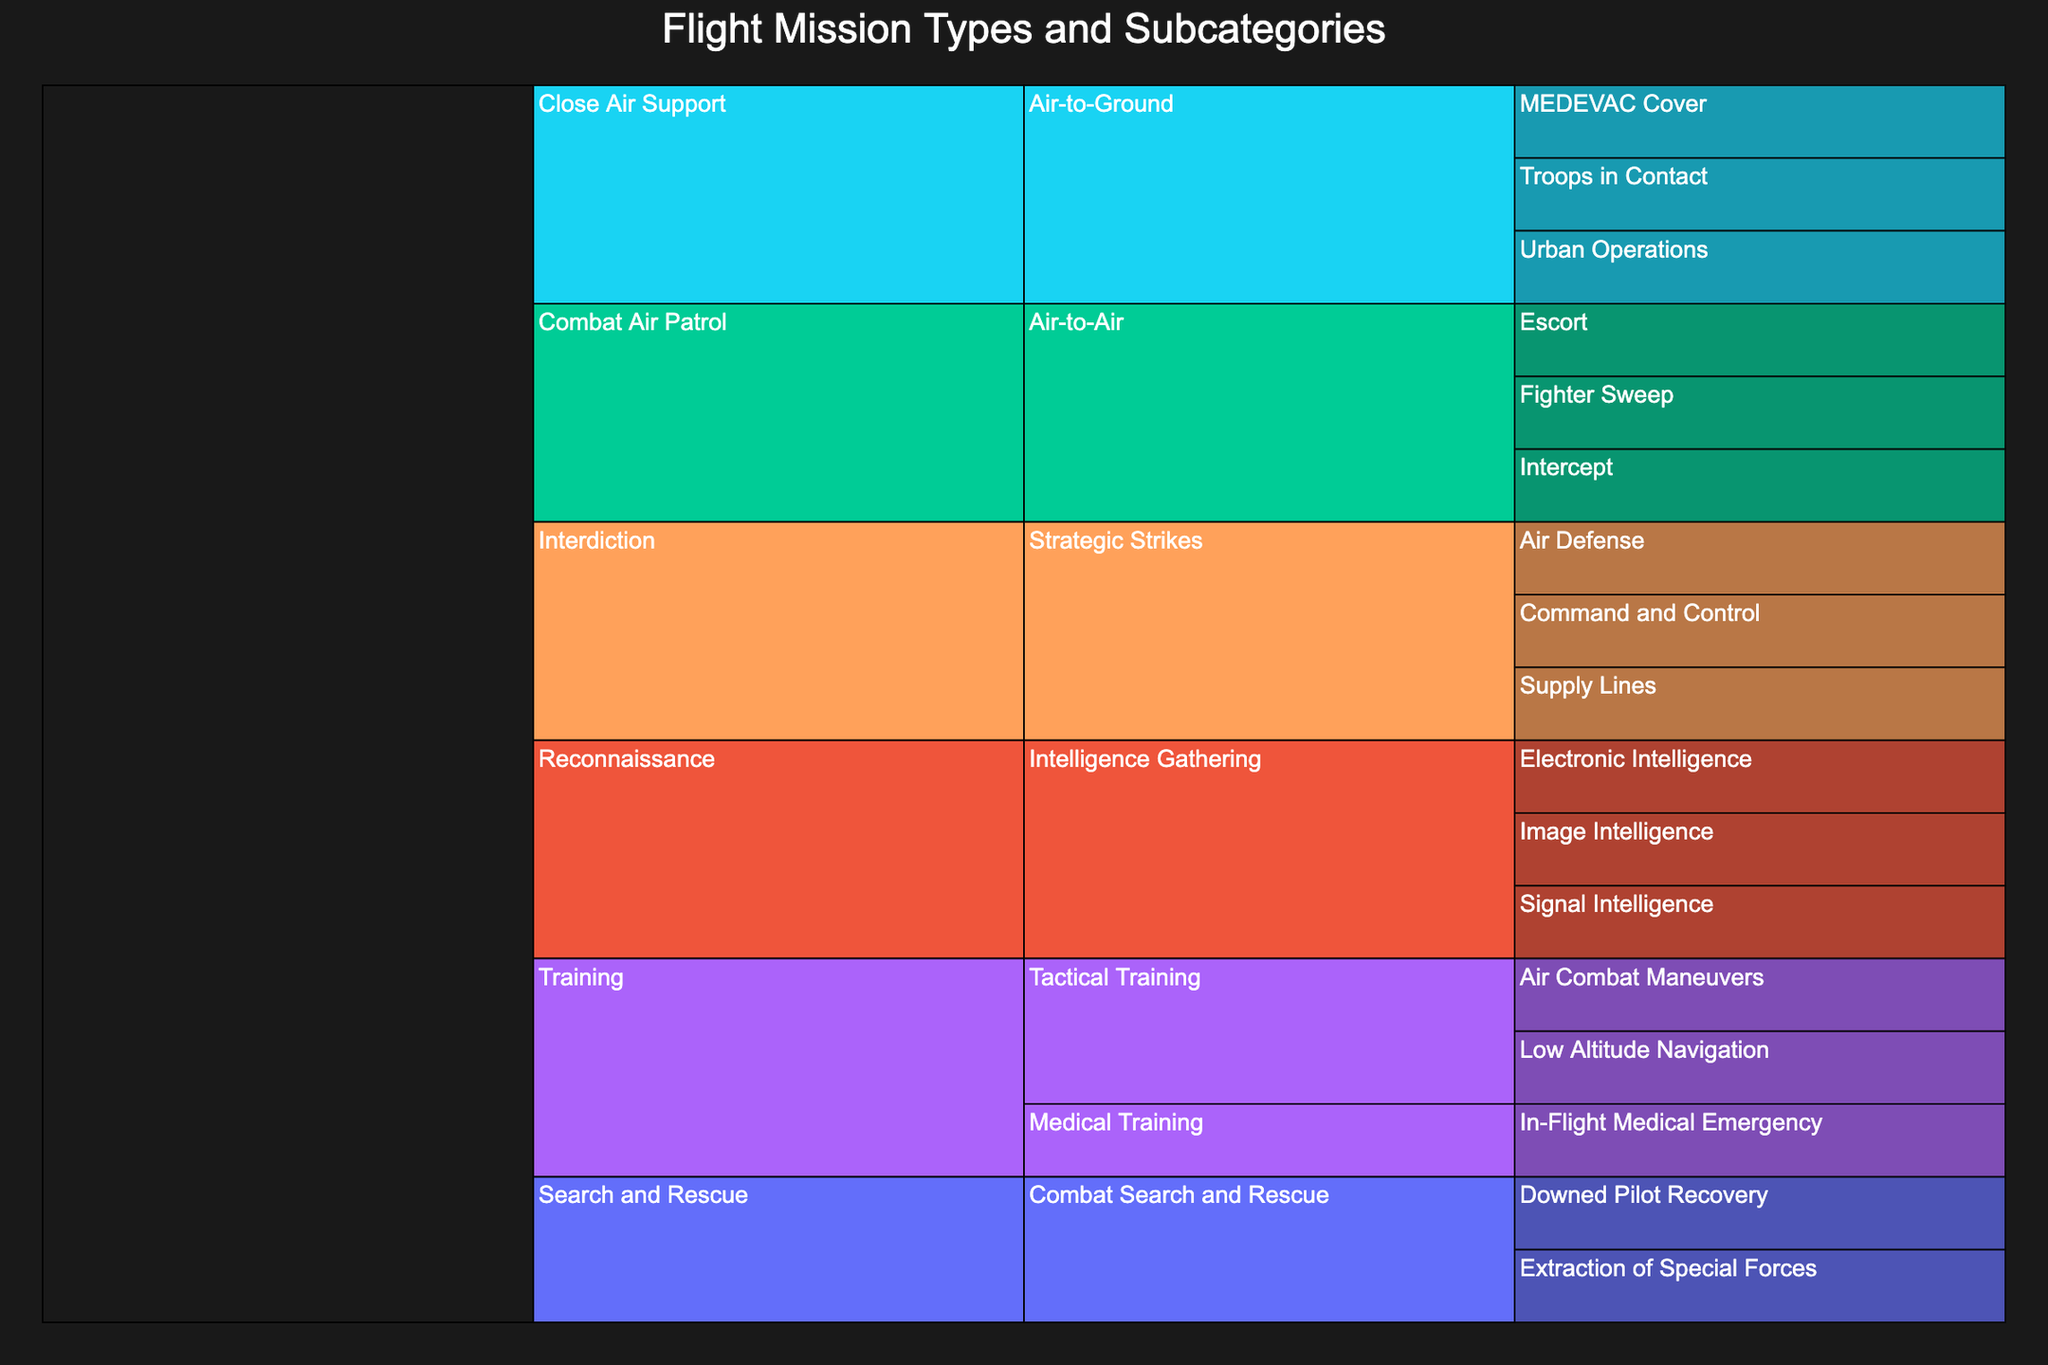What is the title of the Icicle Chart? The title of the figure is typically displayed at the top and is meant to provide a summary of the visualized data. The title is "Flight Mission Types and Subcategories".
Answer: Flight Mission Types and Subcategories How many main mission types are represented in the chart? The main mission types are the top-level categories in the Icicle Chart. There are five main mission types: Combat Air Patrol, Close Air Support, Interdiction, Reconnaissance, and Search and Rescue.
Answer: Five Which mission type has the category "Air-to-Ground"? The categories are nested under each mission type. The mission type that includes the "Air-to-Ground" category is Close Air Support.
Answer: Close Air Support How many subcategories are under the mission type "Combat Air Patrol"? "Combat Air Patrol" is a mission type with its own set of subcategories. By counting, we see that it has three subcategories: Fighter Sweep, Intercept, and Escort.
Answer: Three What is the subcategory within "Command and Control"? "Command and Control" is not a mission type but falls under the category "Strategic Strikes" which is part of the "Interdiction" mission type. The subcategory directly under "Command and Control" should logically be the one identified by it. The immediate subcategory is Command and Control itself.
Answer: Command and Control Under which main mission type does "Downed Pilot Recovery" fall? "Downed Pilot Recovery" is a specific subcategory. To find its main mission type, trace it to its top-most parent node. "Downed Pilot Recovery" falls under Combat Search and Rescue, which is a part of Search and Rescue.
Answer: Search and Rescue How many subcategories are under the "Medical Training" category? "Medical Training" is a category within the Training mission type. By counting, it has one subcategory: In-Flight Medical Emergency.
Answer: One Which mission type has the highest number of categories? Each mission type is categorized further. By counting the categories under each mission type, we find that Training has the highest number of categories: Tactical Training and Medical Training.
Answer: Training Compare the number of subcategories under "Intelligence Gathering" versus "Strategic Strikes". To compare, count the subcategories under each category: "Intelligence Gathering" has 3 subcategories (Image Intelligence, Electronic Intelligence, Signal Intelligence), whereas "Strategic Strikes" has 3 subcategories (Command and Control, Supply Lines, Air Defense). The numbers are the same.
Answer: Equal with three each What type of mission is "MEDEVAC Cover" associated with? "MEDEVAC Cover" is a subcategory. To find out its associated mission type, track up through the chart to its main mission type. "MEDEVAC Cover" is within the "Air-to-Ground" category, which is under Close Air Support.
Answer: Close Air Support 